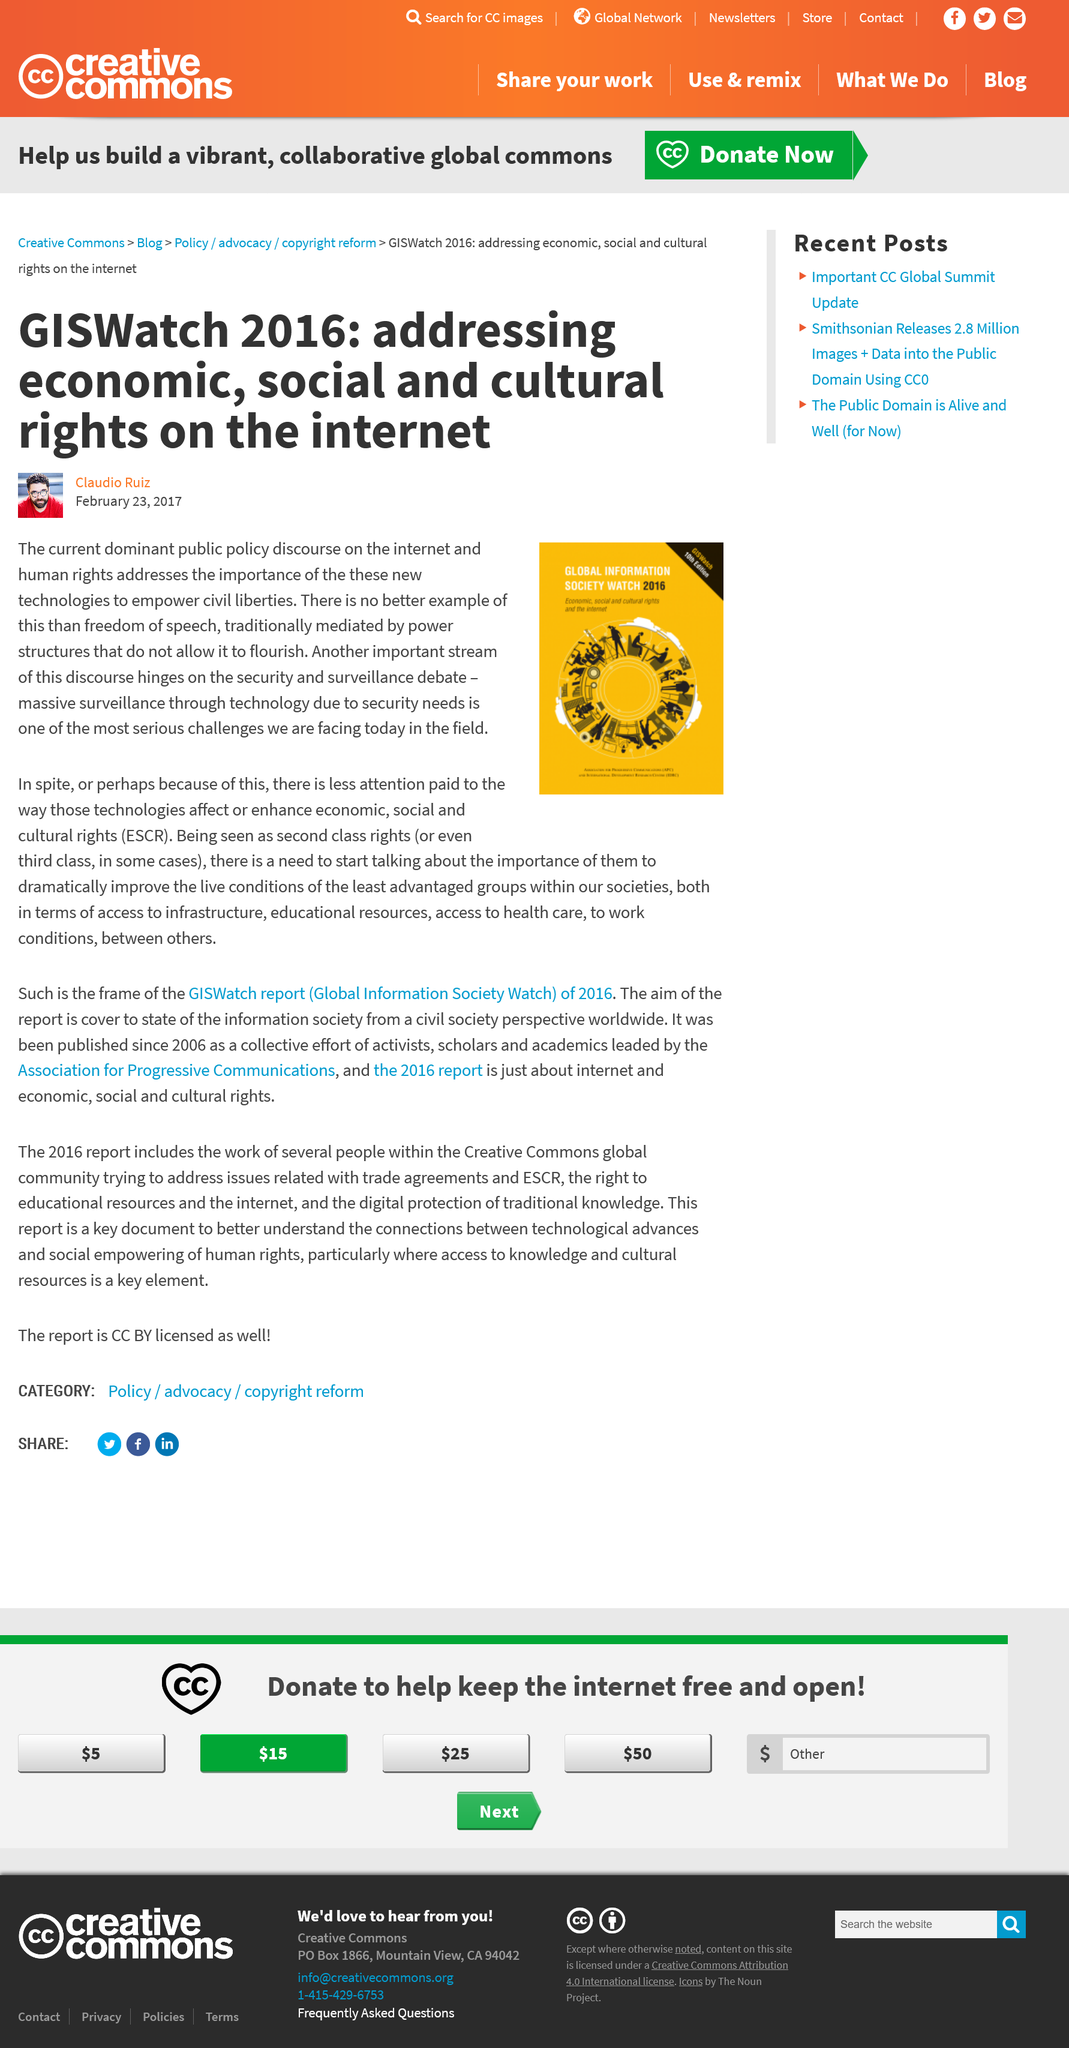Give some essential details in this illustration. Yes, Claudio Ruiz is the author. The 10th edition of GISWatch is focused on addressing economic, social, and cultural rights on the internet. 